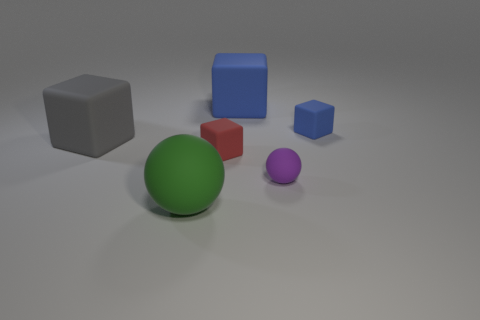Are there any large spheres behind the gray rubber object?
Offer a terse response. No. How many large blue objects are the same material as the tiny purple sphere?
Give a very brief answer. 1. What number of things are either large blue matte objects or gray objects?
Give a very brief answer. 2. Is there a tiny shiny object?
Your response must be concise. No. What is the tiny cube that is in front of the large matte thing that is left of the ball that is on the left side of the red rubber cube made of?
Give a very brief answer. Rubber. Are there fewer blue blocks that are on the left side of the purple rubber thing than big brown rubber objects?
Your response must be concise. No. There is a blue block that is the same size as the green matte sphere; what is it made of?
Offer a terse response. Rubber. What is the size of the thing that is both in front of the red matte cube and behind the green thing?
Offer a very short reply. Small. What is the size of the gray thing that is the same shape as the red thing?
Your answer should be compact. Large. What number of objects are balls or spheres that are in front of the tiny sphere?
Ensure brevity in your answer.  2. 